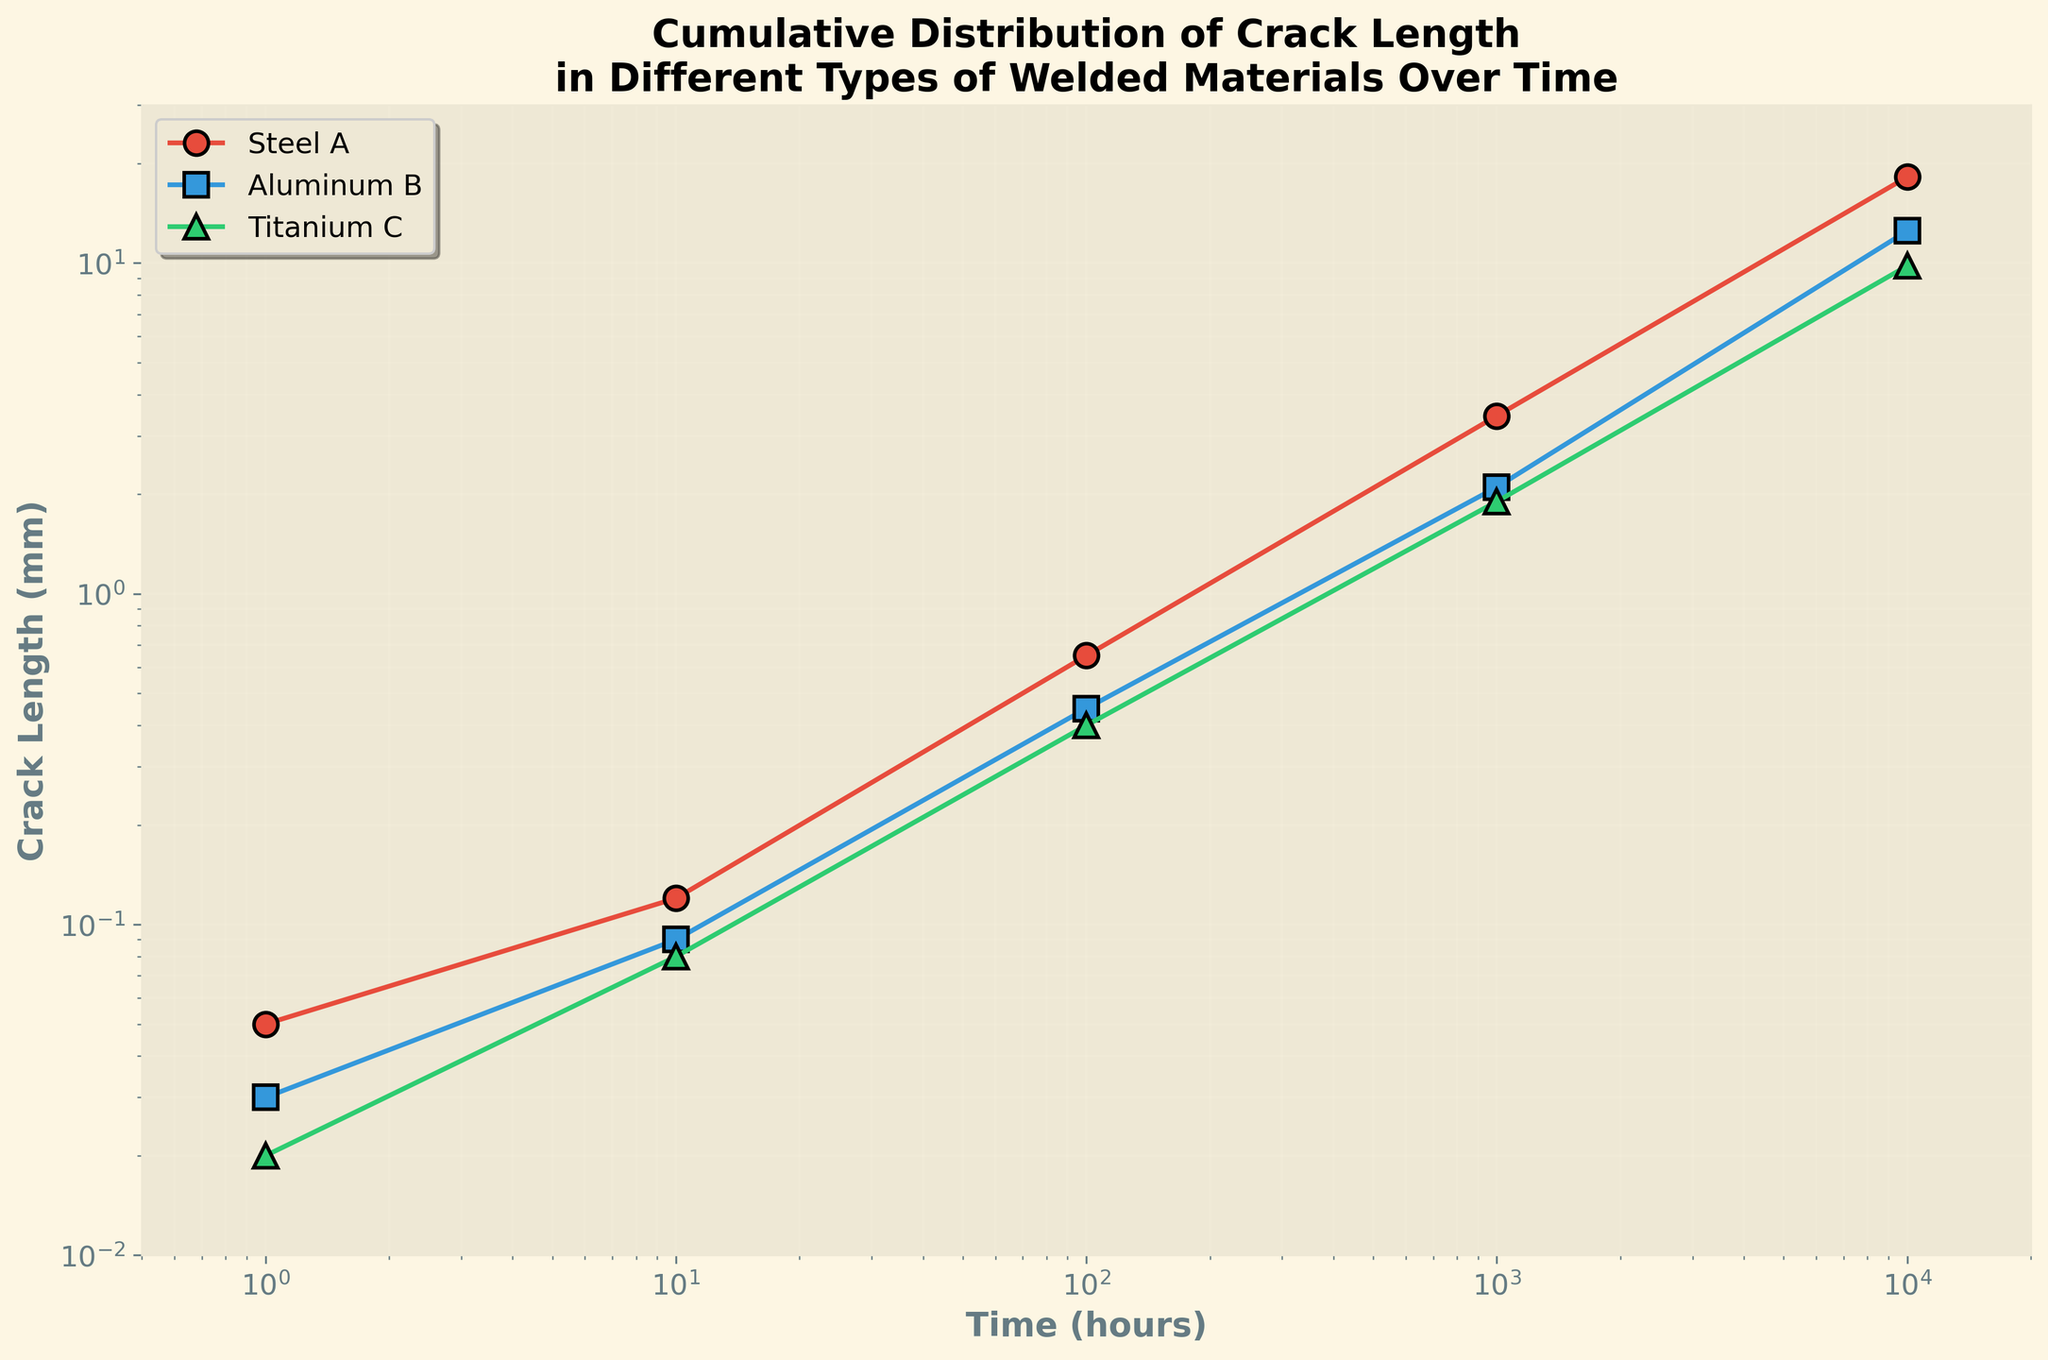What's the title of the figure? The title of the figure is displayed at the top.
Answer: Cumulative Distribution of Crack Length in Different Types of Welded Materials Over Time What does the x-axis represent? The label under the x-axis defines what it represents.
Answer: Time (hours) How is the data for Steel A distributed over time compared to Aluminum B? By observing the two lines corresponding to Steel A and Aluminum B on the log-log plot, we can see the difference in the crack length increment over time. Steel A shows a sharper increase in crack length at higher times compared to Aluminum B.
Answer: Steel A increases more sharply At 10,000 hours, which material has the longest crack length? By locating the time of 10,000 hours on the x-axis and checking the corresponding y-values for each material, we can identify which one has the longest crack.
Answer: Steel A Which material has the smallest initial crack length at 1 hour? Check the values at the 1-hour mark on the x-axis for each material and compare their crack lengths.
Answer: Titanium C How does the crack length of Aluminum B change from 100 hours to 1000 hours? Observing the curve for Aluminum B between 100 and 1000 hours, locate the points on the log scale at these times and note their vertical positions. Calculate the change in crack length.
Answer: Increase by 1.65 mm Which material shows the least overall increase in crack length over time? Compare the differences in crack lengths from 1 hour to 10,000 hours for all materials. Find the material that has the smallest change.
Answer: Titanium C At 100 hours, which material has the longest crack length and what is the length? Identify the point on the plot corresponding to 100 hours for each material and compare their crack lengths.
Answer: Steel A has 0.65 mm Which material shows the fastest crack growth rate initially (from 1 hour to 10 hours)? Examine the initial segment of each material's curve from 1 to 10 hours to see which one has the steepest upward slope.
Answer: Steel A 